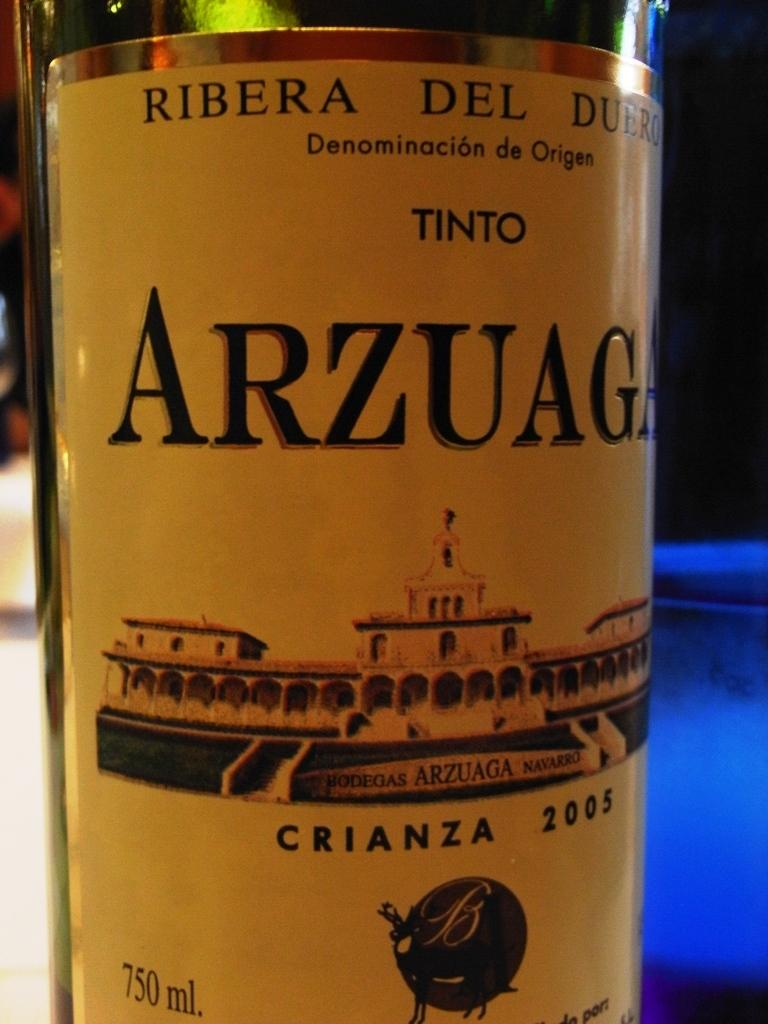<image>
Describe the image concisely. a Arzuag bottle that is on a blue table 